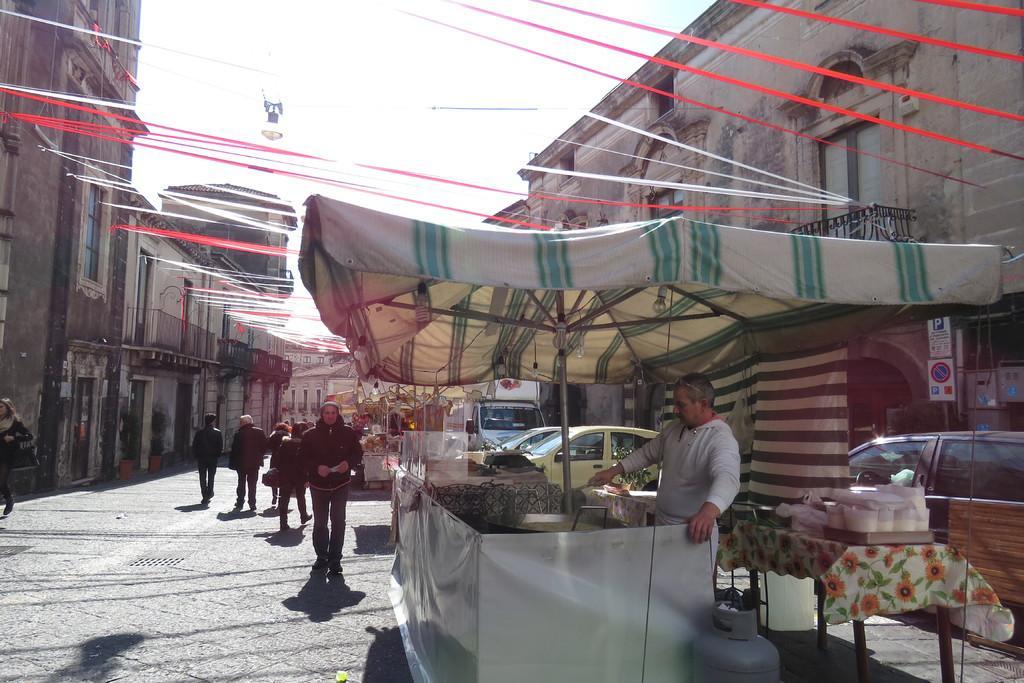In one or two sentences, can you explain what this image depicts? In this image there are few vehicles and shops on the road, there are few ribbons in between the buildings, a light hanging from one of the ribbons and the sky. 